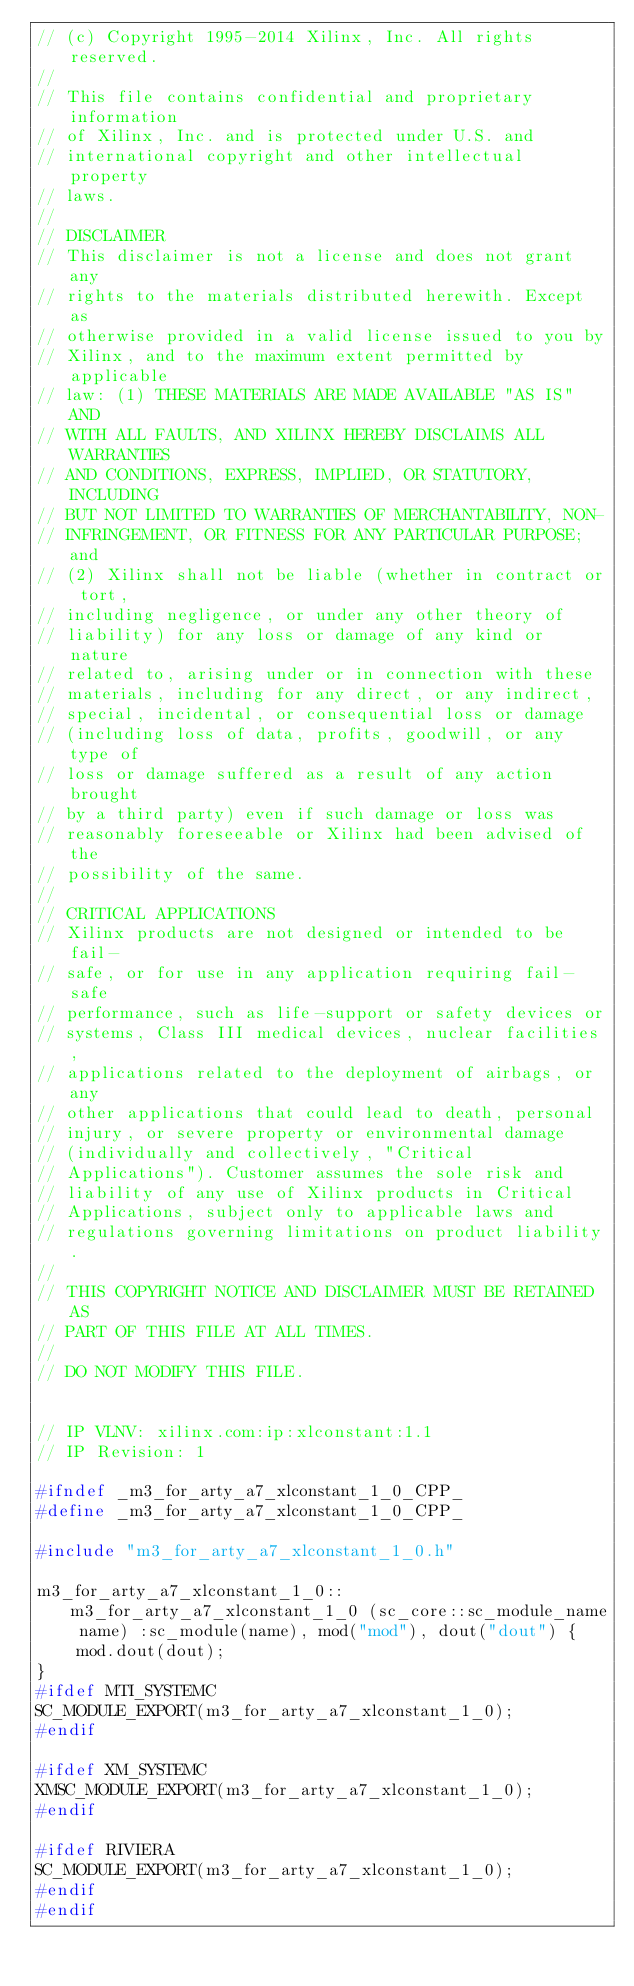Convert code to text. <code><loc_0><loc_0><loc_500><loc_500><_C++_>// (c) Copyright 1995-2014 Xilinx, Inc. All rights reserved.
// 
// This file contains confidential and proprietary information
// of Xilinx, Inc. and is protected under U.S. and
// international copyright and other intellectual property
// laws.
// 
// DISCLAIMER
// This disclaimer is not a license and does not grant any
// rights to the materials distributed herewith. Except as
// otherwise provided in a valid license issued to you by
// Xilinx, and to the maximum extent permitted by applicable
// law: (1) THESE MATERIALS ARE MADE AVAILABLE "AS IS" AND
// WITH ALL FAULTS, AND XILINX HEREBY DISCLAIMS ALL WARRANTIES
// AND CONDITIONS, EXPRESS, IMPLIED, OR STATUTORY, INCLUDING
// BUT NOT LIMITED TO WARRANTIES OF MERCHANTABILITY, NON-
// INFRINGEMENT, OR FITNESS FOR ANY PARTICULAR PURPOSE; and
// (2) Xilinx shall not be liable (whether in contract or tort,
// including negligence, or under any other theory of
// liability) for any loss or damage of any kind or nature
// related to, arising under or in connection with these
// materials, including for any direct, or any indirect,
// special, incidental, or consequential loss or damage
// (including loss of data, profits, goodwill, or any type of
// loss or damage suffered as a result of any action brought
// by a third party) even if such damage or loss was
// reasonably foreseeable or Xilinx had been advised of the
// possibility of the same.
// 
// CRITICAL APPLICATIONS
// Xilinx products are not designed or intended to be fail-
// safe, or for use in any application requiring fail-safe
// performance, such as life-support or safety devices or
// systems, Class III medical devices, nuclear facilities,
// applications related to the deployment of airbags, or any
// other applications that could lead to death, personal
// injury, or severe property or environmental damage
// (individually and collectively, "Critical
// Applications"). Customer assumes the sole risk and
// liability of any use of Xilinx products in Critical
// Applications, subject only to applicable laws and
// regulations governing limitations on product liability.
// 
// THIS COPYRIGHT NOTICE AND DISCLAIMER MUST BE RETAINED AS
// PART OF THIS FILE AT ALL TIMES.
// 
// DO NOT MODIFY THIS FILE.


// IP VLNV: xilinx.com:ip:xlconstant:1.1
// IP Revision: 1

#ifndef _m3_for_arty_a7_xlconstant_1_0_CPP_
#define _m3_for_arty_a7_xlconstant_1_0_CPP_

#include "m3_for_arty_a7_xlconstant_1_0.h"

m3_for_arty_a7_xlconstant_1_0::m3_for_arty_a7_xlconstant_1_0 (sc_core::sc_module_name name) :sc_module(name), mod("mod"), dout("dout") {
    mod.dout(dout);
}
#ifdef MTI_SYSTEMC
SC_MODULE_EXPORT(m3_for_arty_a7_xlconstant_1_0);
#endif

#ifdef XM_SYSTEMC
XMSC_MODULE_EXPORT(m3_for_arty_a7_xlconstant_1_0);
#endif

#ifdef RIVIERA
SC_MODULE_EXPORT(m3_for_arty_a7_xlconstant_1_0);
#endif
#endif

</code> 